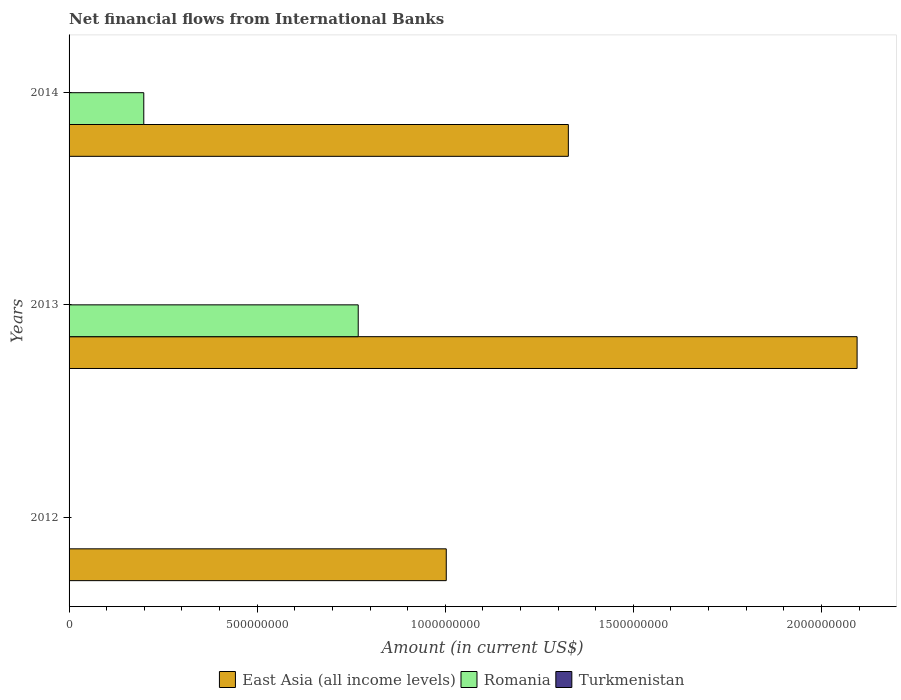Are the number of bars per tick equal to the number of legend labels?
Your answer should be compact. No. Are the number of bars on each tick of the Y-axis equal?
Your response must be concise. No. How many bars are there on the 1st tick from the top?
Your answer should be compact. 2. How many bars are there on the 3rd tick from the bottom?
Your response must be concise. 2. Across all years, what is the maximum net financial aid flows in East Asia (all income levels)?
Provide a short and direct response. 2.09e+09. Across all years, what is the minimum net financial aid flows in Romania?
Keep it short and to the point. 0. In which year was the net financial aid flows in Romania maximum?
Offer a very short reply. 2013. What is the total net financial aid flows in Romania in the graph?
Give a very brief answer. 9.67e+08. What is the difference between the net financial aid flows in East Asia (all income levels) in 2012 and that in 2013?
Offer a terse response. -1.09e+09. What is the average net financial aid flows in Romania per year?
Make the answer very short. 3.22e+08. In the year 2014, what is the difference between the net financial aid flows in East Asia (all income levels) and net financial aid flows in Romania?
Ensure brevity in your answer.  1.13e+09. In how many years, is the net financial aid flows in Turkmenistan greater than 1700000000 US$?
Offer a very short reply. 0. What is the ratio of the net financial aid flows in East Asia (all income levels) in 2012 to that in 2014?
Your answer should be compact. 0.76. Is the net financial aid flows in East Asia (all income levels) in 2013 less than that in 2014?
Your response must be concise. No. What is the difference between the highest and the second highest net financial aid flows in East Asia (all income levels)?
Make the answer very short. 7.68e+08. What is the difference between the highest and the lowest net financial aid flows in Romania?
Provide a short and direct response. 7.69e+08. In how many years, is the net financial aid flows in East Asia (all income levels) greater than the average net financial aid flows in East Asia (all income levels) taken over all years?
Provide a short and direct response. 1. How many bars are there?
Your answer should be compact. 5. Are all the bars in the graph horizontal?
Your response must be concise. Yes. How many years are there in the graph?
Provide a short and direct response. 3. Where does the legend appear in the graph?
Provide a succinct answer. Bottom center. How many legend labels are there?
Your answer should be very brief. 3. How are the legend labels stacked?
Ensure brevity in your answer.  Horizontal. What is the title of the graph?
Make the answer very short. Net financial flows from International Banks. What is the label or title of the X-axis?
Offer a terse response. Amount (in current US$). What is the Amount (in current US$) of East Asia (all income levels) in 2012?
Keep it short and to the point. 1.00e+09. What is the Amount (in current US$) of East Asia (all income levels) in 2013?
Provide a succinct answer. 2.09e+09. What is the Amount (in current US$) of Romania in 2013?
Make the answer very short. 7.69e+08. What is the Amount (in current US$) of East Asia (all income levels) in 2014?
Offer a very short reply. 1.33e+09. What is the Amount (in current US$) in Romania in 2014?
Your answer should be very brief. 1.99e+08. What is the Amount (in current US$) of Turkmenistan in 2014?
Your answer should be very brief. 0. Across all years, what is the maximum Amount (in current US$) of East Asia (all income levels)?
Keep it short and to the point. 2.09e+09. Across all years, what is the maximum Amount (in current US$) of Romania?
Provide a succinct answer. 7.69e+08. Across all years, what is the minimum Amount (in current US$) in East Asia (all income levels)?
Make the answer very short. 1.00e+09. Across all years, what is the minimum Amount (in current US$) of Romania?
Give a very brief answer. 0. What is the total Amount (in current US$) in East Asia (all income levels) in the graph?
Offer a terse response. 4.43e+09. What is the total Amount (in current US$) of Romania in the graph?
Ensure brevity in your answer.  9.67e+08. What is the difference between the Amount (in current US$) of East Asia (all income levels) in 2012 and that in 2013?
Ensure brevity in your answer.  -1.09e+09. What is the difference between the Amount (in current US$) in East Asia (all income levels) in 2012 and that in 2014?
Your answer should be compact. -3.25e+08. What is the difference between the Amount (in current US$) of East Asia (all income levels) in 2013 and that in 2014?
Ensure brevity in your answer.  7.68e+08. What is the difference between the Amount (in current US$) in Romania in 2013 and that in 2014?
Offer a terse response. 5.70e+08. What is the difference between the Amount (in current US$) in East Asia (all income levels) in 2012 and the Amount (in current US$) in Romania in 2013?
Your answer should be compact. 2.34e+08. What is the difference between the Amount (in current US$) in East Asia (all income levels) in 2012 and the Amount (in current US$) in Romania in 2014?
Offer a terse response. 8.04e+08. What is the difference between the Amount (in current US$) in East Asia (all income levels) in 2013 and the Amount (in current US$) in Romania in 2014?
Ensure brevity in your answer.  1.90e+09. What is the average Amount (in current US$) of East Asia (all income levels) per year?
Ensure brevity in your answer.  1.48e+09. What is the average Amount (in current US$) of Romania per year?
Your response must be concise. 3.22e+08. What is the average Amount (in current US$) in Turkmenistan per year?
Make the answer very short. 0. In the year 2013, what is the difference between the Amount (in current US$) in East Asia (all income levels) and Amount (in current US$) in Romania?
Your answer should be very brief. 1.33e+09. In the year 2014, what is the difference between the Amount (in current US$) in East Asia (all income levels) and Amount (in current US$) in Romania?
Your response must be concise. 1.13e+09. What is the ratio of the Amount (in current US$) of East Asia (all income levels) in 2012 to that in 2013?
Provide a short and direct response. 0.48. What is the ratio of the Amount (in current US$) in East Asia (all income levels) in 2012 to that in 2014?
Keep it short and to the point. 0.76. What is the ratio of the Amount (in current US$) of East Asia (all income levels) in 2013 to that in 2014?
Provide a succinct answer. 1.58. What is the ratio of the Amount (in current US$) of Romania in 2013 to that in 2014?
Keep it short and to the point. 3.87. What is the difference between the highest and the second highest Amount (in current US$) of East Asia (all income levels)?
Provide a succinct answer. 7.68e+08. What is the difference between the highest and the lowest Amount (in current US$) of East Asia (all income levels)?
Make the answer very short. 1.09e+09. What is the difference between the highest and the lowest Amount (in current US$) of Romania?
Offer a terse response. 7.69e+08. 